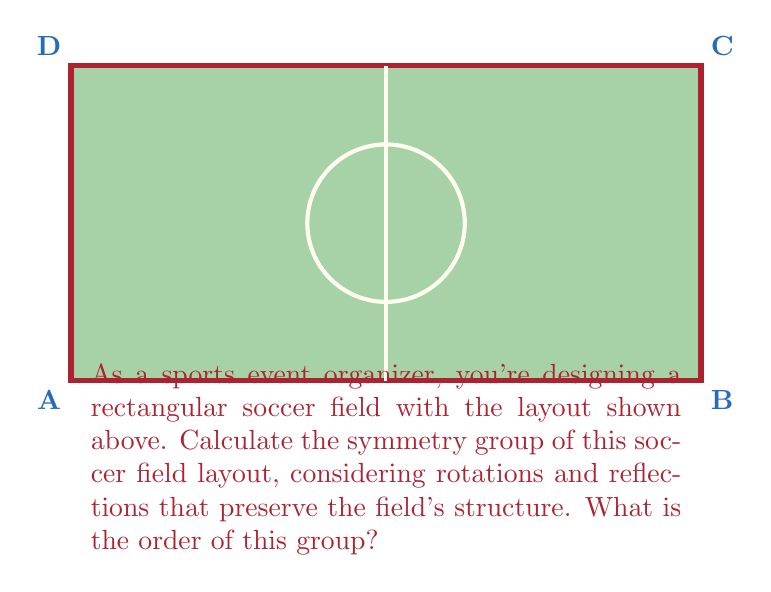Help me with this question. To determine the symmetry group of the soccer field layout, we need to identify all the symmetries that preserve its structure:

1) Rotations:
   - Identity (0° rotation)
   - 180° rotation around the center

2) Reflections:
   - Horizontal reflection across the midfield line
   - Vertical reflection across the center line
   - Two diagonal reflections (from corner to corner)

These symmetries form a group under composition. Let's identify this group:

1) It has 8 elements in total:
   - e (identity)
   - r (180° rotation)
   - h (horizontal reflection)
   - v (vertical reflection)
   - d1, d2 (diagonal reflections)
   - hv, vh (composition of horizontal and vertical reflections)

2) The composition table of these elements matches that of the dihedral group D4, which is the symmetry group of a square.

3) The group has the following properties:
   - It's non-abelian (e.g., hv ≠ vh)
   - It has order 8
   - It's generated by two elements: r and h (or r and v)

Therefore, the symmetry group of this soccer field layout is isomorphic to D4, the dihedral group of order 8.

The order of this group is 8, which can be expressed as $|D_4| = 8$.
Answer: $D_4$, order 8 